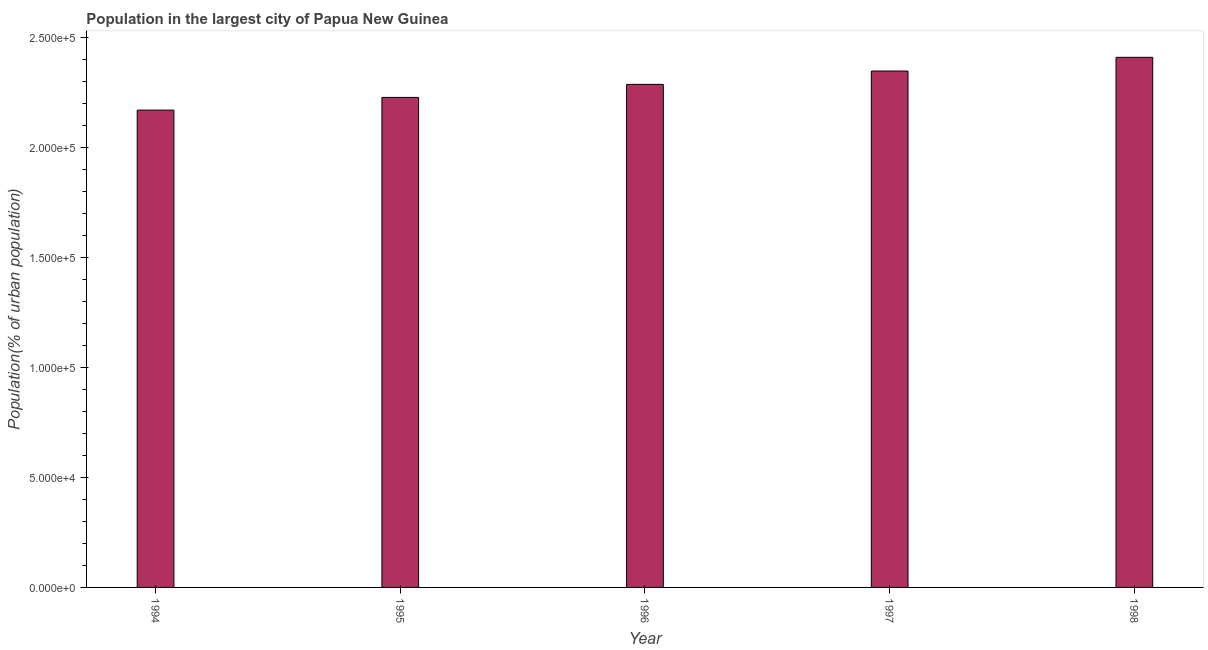Does the graph contain any zero values?
Keep it short and to the point. No. What is the title of the graph?
Give a very brief answer. Population in the largest city of Papua New Guinea. What is the label or title of the X-axis?
Provide a short and direct response. Year. What is the label or title of the Y-axis?
Offer a very short reply. Population(% of urban population). What is the population in largest city in 1994?
Provide a succinct answer. 2.17e+05. Across all years, what is the maximum population in largest city?
Your answer should be very brief. 2.41e+05. Across all years, what is the minimum population in largest city?
Provide a short and direct response. 2.17e+05. What is the sum of the population in largest city?
Offer a terse response. 1.14e+06. What is the difference between the population in largest city in 1996 and 1998?
Your response must be concise. -1.23e+04. What is the average population in largest city per year?
Give a very brief answer. 2.29e+05. What is the median population in largest city?
Offer a very short reply. 2.29e+05. Do a majority of the years between 1995 and 1996 (inclusive) have population in largest city greater than 50000 %?
Your answer should be compact. Yes. What is the difference between the highest and the second highest population in largest city?
Keep it short and to the point. 6236. What is the difference between the highest and the lowest population in largest city?
Your response must be concise. 2.40e+04. In how many years, is the population in largest city greater than the average population in largest city taken over all years?
Ensure brevity in your answer.  2. How many bars are there?
Provide a succinct answer. 5. Are all the bars in the graph horizontal?
Provide a short and direct response. No. What is the difference between two consecutive major ticks on the Y-axis?
Make the answer very short. 5.00e+04. Are the values on the major ticks of Y-axis written in scientific E-notation?
Offer a terse response. Yes. What is the Population(% of urban population) of 1994?
Ensure brevity in your answer.  2.17e+05. What is the Population(% of urban population) in 1995?
Offer a terse response. 2.23e+05. What is the Population(% of urban population) in 1996?
Your response must be concise. 2.29e+05. What is the Population(% of urban population) of 1997?
Make the answer very short. 2.35e+05. What is the Population(% of urban population) of 1998?
Provide a succinct answer. 2.41e+05. What is the difference between the Population(% of urban population) in 1994 and 1995?
Offer a terse response. -5765. What is the difference between the Population(% of urban population) in 1994 and 1996?
Your answer should be very brief. -1.17e+04. What is the difference between the Population(% of urban population) in 1994 and 1997?
Your answer should be very brief. -1.78e+04. What is the difference between the Population(% of urban population) in 1994 and 1998?
Keep it short and to the point. -2.40e+04. What is the difference between the Population(% of urban population) in 1995 and 1996?
Give a very brief answer. -5926. What is the difference between the Population(% of urban population) in 1995 and 1997?
Ensure brevity in your answer.  -1.20e+04. What is the difference between the Population(% of urban population) in 1995 and 1998?
Provide a succinct answer. -1.82e+04. What is the difference between the Population(% of urban population) in 1996 and 1997?
Offer a terse response. -6067. What is the difference between the Population(% of urban population) in 1996 and 1998?
Your answer should be compact. -1.23e+04. What is the difference between the Population(% of urban population) in 1997 and 1998?
Your answer should be very brief. -6236. What is the ratio of the Population(% of urban population) in 1994 to that in 1995?
Give a very brief answer. 0.97. What is the ratio of the Population(% of urban population) in 1994 to that in 1996?
Make the answer very short. 0.95. What is the ratio of the Population(% of urban population) in 1994 to that in 1997?
Keep it short and to the point. 0.92. What is the ratio of the Population(% of urban population) in 1994 to that in 1998?
Keep it short and to the point. 0.9. What is the ratio of the Population(% of urban population) in 1995 to that in 1996?
Ensure brevity in your answer.  0.97. What is the ratio of the Population(% of urban population) in 1995 to that in 1997?
Your answer should be compact. 0.95. What is the ratio of the Population(% of urban population) in 1995 to that in 1998?
Your answer should be very brief. 0.92. What is the ratio of the Population(% of urban population) in 1996 to that in 1998?
Give a very brief answer. 0.95. 